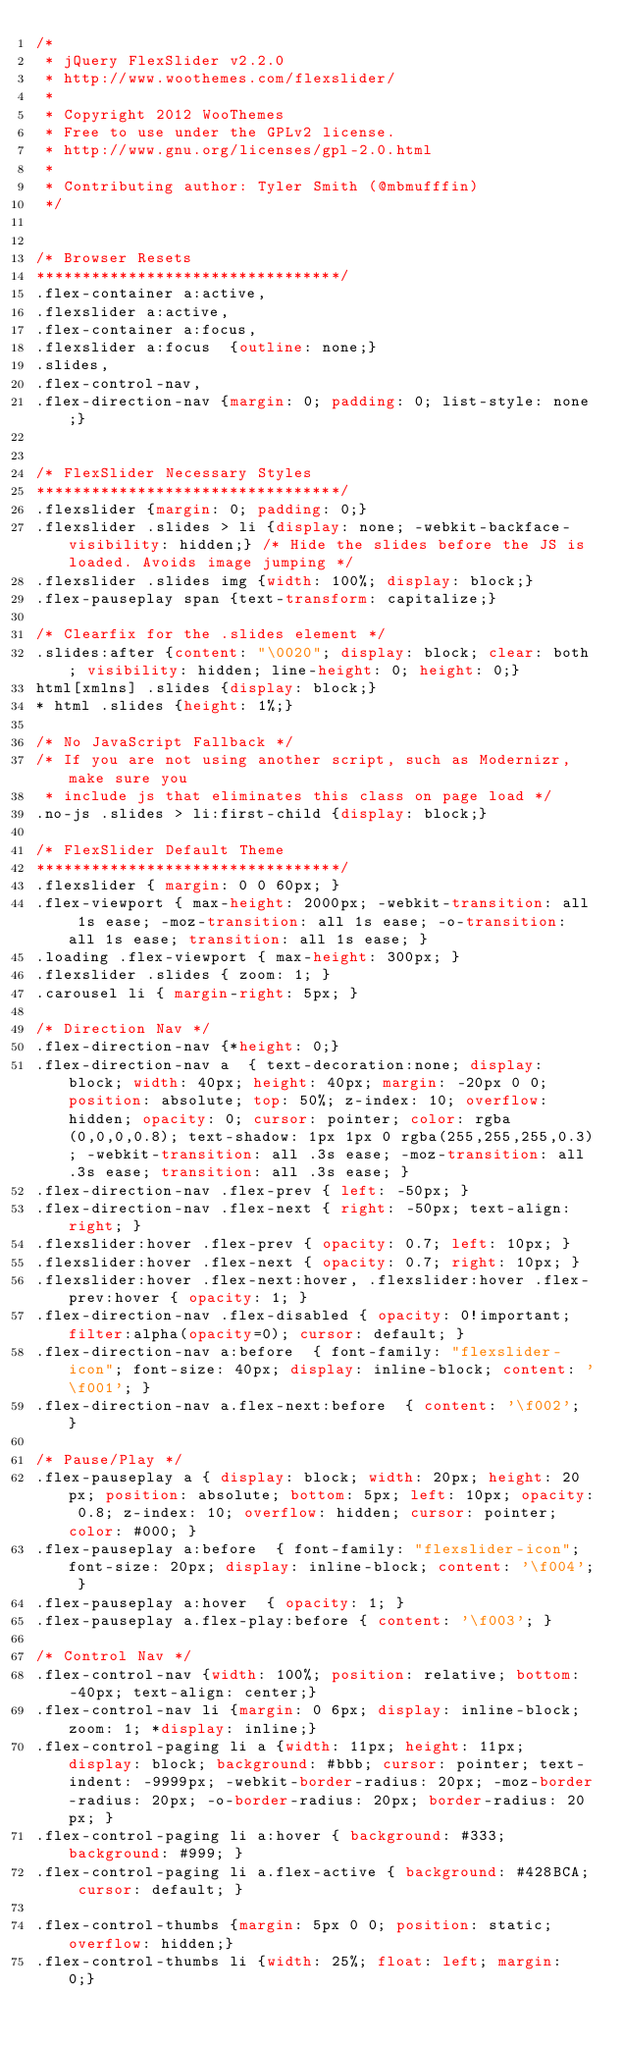<code> <loc_0><loc_0><loc_500><loc_500><_CSS_>/*
 * jQuery FlexSlider v2.2.0
 * http://www.woothemes.com/flexslider/
 *
 * Copyright 2012 WooThemes
 * Free to use under the GPLv2 license.
 * http://www.gnu.org/licenses/gpl-2.0.html
 *
 * Contributing author: Tyler Smith (@mbmufffin)
 */


/* Browser Resets
*********************************/
.flex-container a:active,
.flexslider a:active,
.flex-container a:focus,
.flexslider a:focus  {outline: none;}
.slides,
.flex-control-nav,
.flex-direction-nav {margin: 0; padding: 0; list-style: none;}


/* FlexSlider Necessary Styles
*********************************/
.flexslider {margin: 0; padding: 0;}
.flexslider .slides > li {display: none; -webkit-backface-visibility: hidden;} /* Hide the slides before the JS is loaded. Avoids image jumping */
.flexslider .slides img {width: 100%; display: block;}
.flex-pauseplay span {text-transform: capitalize;}

/* Clearfix for the .slides element */
.slides:after {content: "\0020"; display: block; clear: both; visibility: hidden; line-height: 0; height: 0;}
html[xmlns] .slides {display: block;}
* html .slides {height: 1%;}

/* No JavaScript Fallback */
/* If you are not using another script, such as Modernizr, make sure you
 * include js that eliminates this class on page load */
.no-js .slides > li:first-child {display: block;}

/* FlexSlider Default Theme
*********************************/
.flexslider { margin: 0 0 60px; }
.flex-viewport { max-height: 2000px; -webkit-transition: all 1s ease; -moz-transition: all 1s ease; -o-transition: all 1s ease; transition: all 1s ease; }
.loading .flex-viewport { max-height: 300px; }
.flexslider .slides { zoom: 1; }
.carousel li { margin-right: 5px; }

/* Direction Nav */
.flex-direction-nav {*height: 0;}
.flex-direction-nav a  { text-decoration:none; display: block; width: 40px; height: 40px; margin: -20px 0 0; position: absolute; top: 50%; z-index: 10; overflow: hidden; opacity: 0; cursor: pointer; color: rgba(0,0,0,0.8); text-shadow: 1px 1px 0 rgba(255,255,255,0.3); -webkit-transition: all .3s ease; -moz-transition: all .3s ease; transition: all .3s ease; }
.flex-direction-nav .flex-prev { left: -50px; }
.flex-direction-nav .flex-next { right: -50px; text-align: right; }
.flexslider:hover .flex-prev { opacity: 0.7; left: 10px; }
.flexslider:hover .flex-next { opacity: 0.7; right: 10px; }
.flexslider:hover .flex-next:hover, .flexslider:hover .flex-prev:hover { opacity: 1; }
.flex-direction-nav .flex-disabled { opacity: 0!important; filter:alpha(opacity=0); cursor: default; }
.flex-direction-nav a:before  { font-family: "flexslider-icon"; font-size: 40px; display: inline-block; content: '\f001'; }
.flex-direction-nav a.flex-next:before  { content: '\f002'; }

/* Pause/Play */
.flex-pauseplay a { display: block; width: 20px; height: 20px; position: absolute; bottom: 5px; left: 10px; opacity: 0.8; z-index: 10; overflow: hidden; cursor: pointer; color: #000; }
.flex-pauseplay a:before  { font-family: "flexslider-icon"; font-size: 20px; display: inline-block; content: '\f004'; }
.flex-pauseplay a:hover  { opacity: 1; }
.flex-pauseplay a.flex-play:before { content: '\f003'; }

/* Control Nav */
.flex-control-nav {width: 100%; position: relative; bottom: -40px; text-align: center;}
.flex-control-nav li {margin: 0 6px; display: inline-block; zoom: 1; *display: inline;}
.flex-control-paging li a {width: 11px; height: 11px; display: block; background: #bbb; cursor: pointer; text-indent: -9999px; -webkit-border-radius: 20px; -moz-border-radius: 20px; -o-border-radius: 20px; border-radius: 20px; }
.flex-control-paging li a:hover { background: #333; background: #999; }
.flex-control-paging li a.flex-active { background: #428BCA; cursor: default; }

.flex-control-thumbs {margin: 5px 0 0; position: static; overflow: hidden;}
.flex-control-thumbs li {width: 25%; float: left; margin: 0;}</code> 